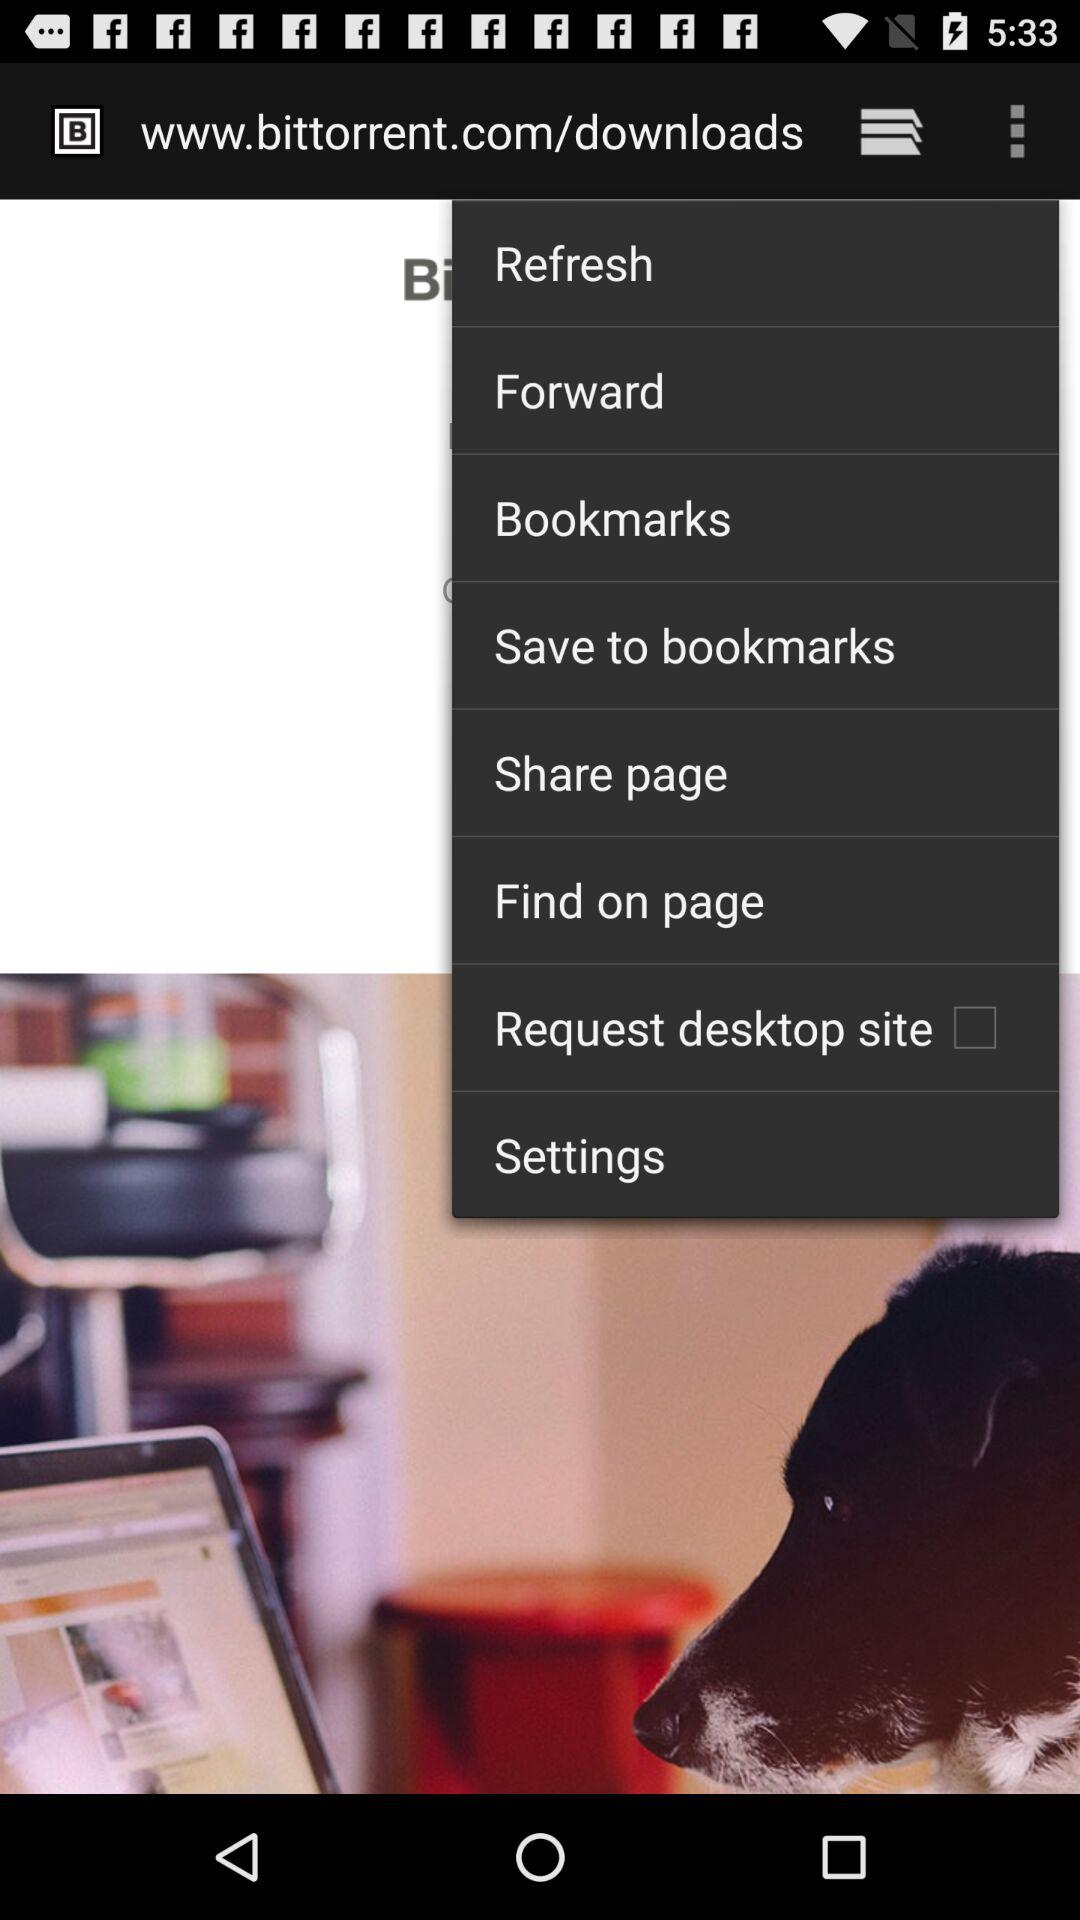What's the status of "Request desktop site"? The status of "Request desktop site" is "off". 